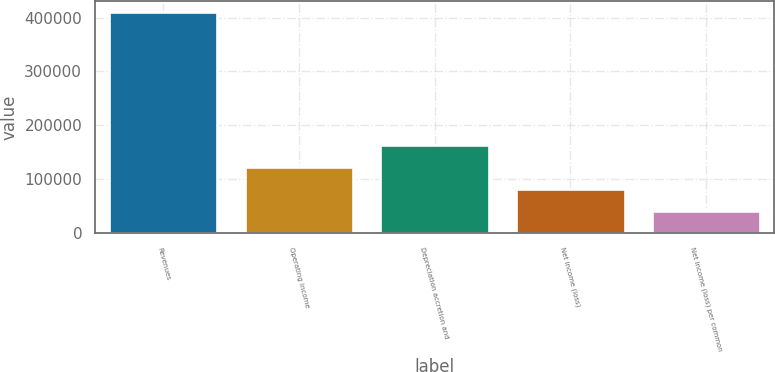Convert chart to OTSL. <chart><loc_0><loc_0><loc_500><loc_500><bar_chart><fcel>Revenues<fcel>Operating income<fcel>Depreciation accretion and<fcel>Net income (loss)<fcel>Net income (loss) per common<nl><fcel>410704<fcel>123211<fcel>164282<fcel>82141<fcel>41070.6<nl></chart> 